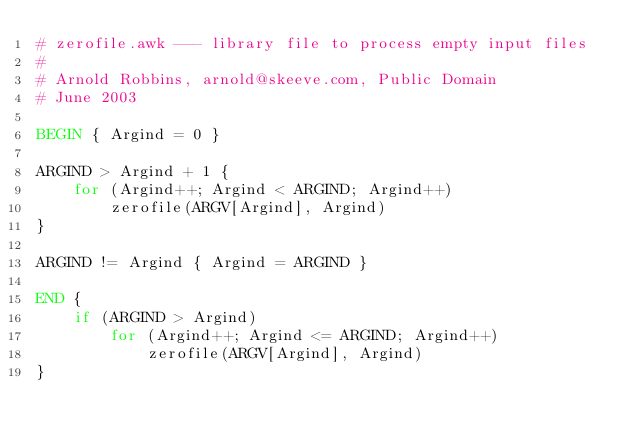Convert code to text. <code><loc_0><loc_0><loc_500><loc_500><_Awk_># zerofile.awk --- library file to process empty input files
#
# Arnold Robbins, arnold@skeeve.com, Public Domain
# June 2003

BEGIN { Argind = 0 }

ARGIND > Argind + 1 {
    for (Argind++; Argind < ARGIND; Argind++)
        zerofile(ARGV[Argind], Argind)
}

ARGIND != Argind { Argind = ARGIND }

END {
    if (ARGIND > Argind)
        for (Argind++; Argind <= ARGIND; Argind++)
            zerofile(ARGV[Argind], Argind)
}
</code> 